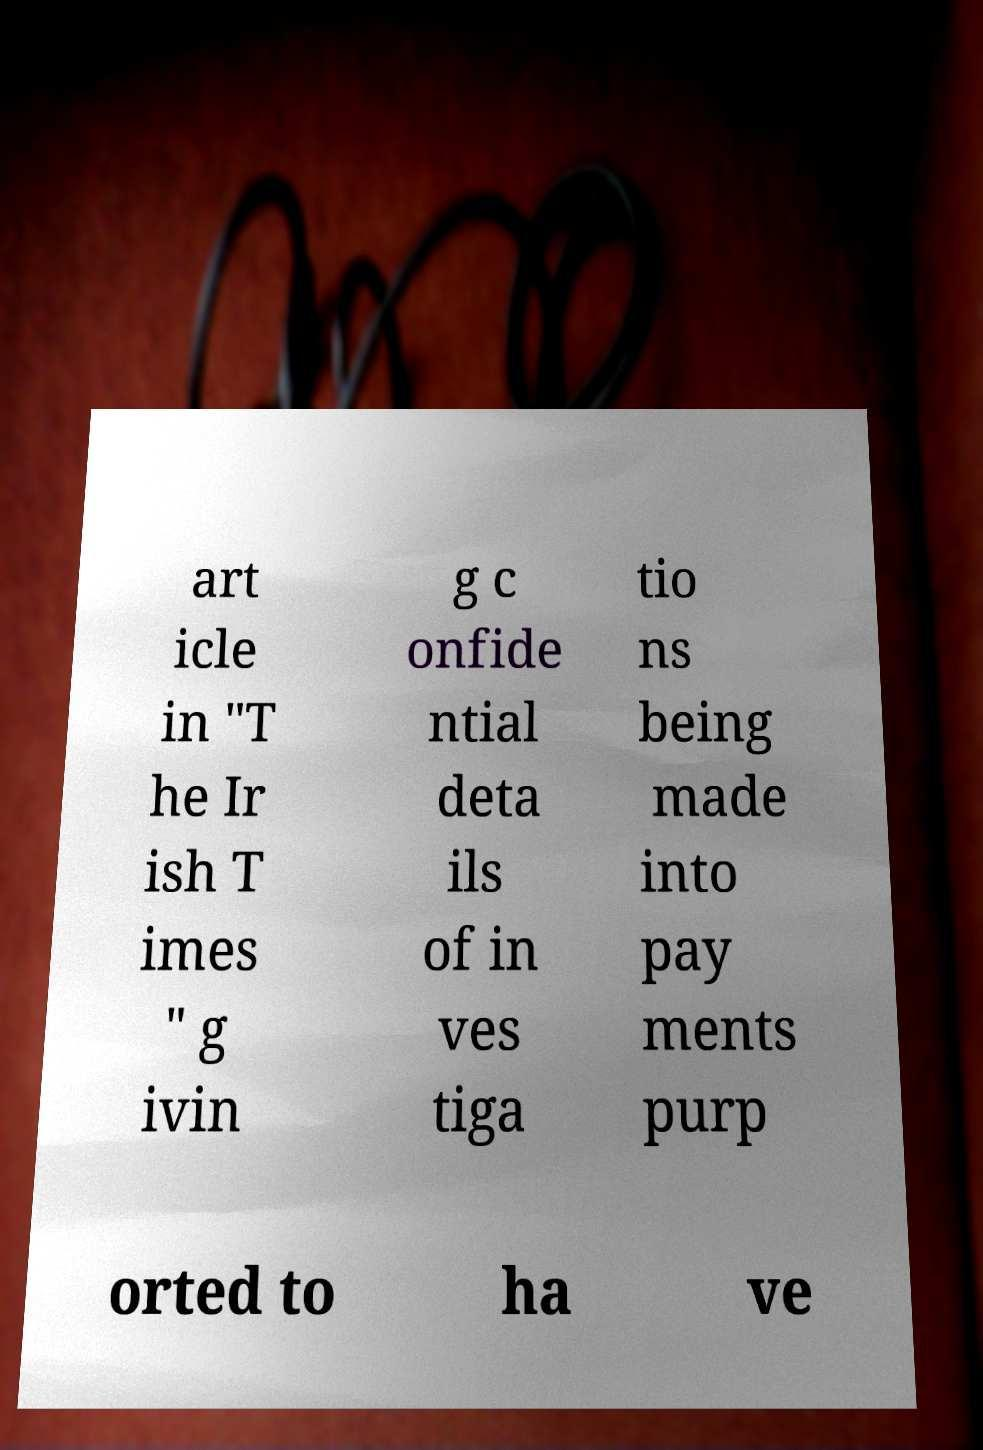Can you accurately transcribe the text from the provided image for me? art icle in "T he Ir ish T imes " g ivin g c onfide ntial deta ils of in ves tiga tio ns being made into pay ments purp orted to ha ve 